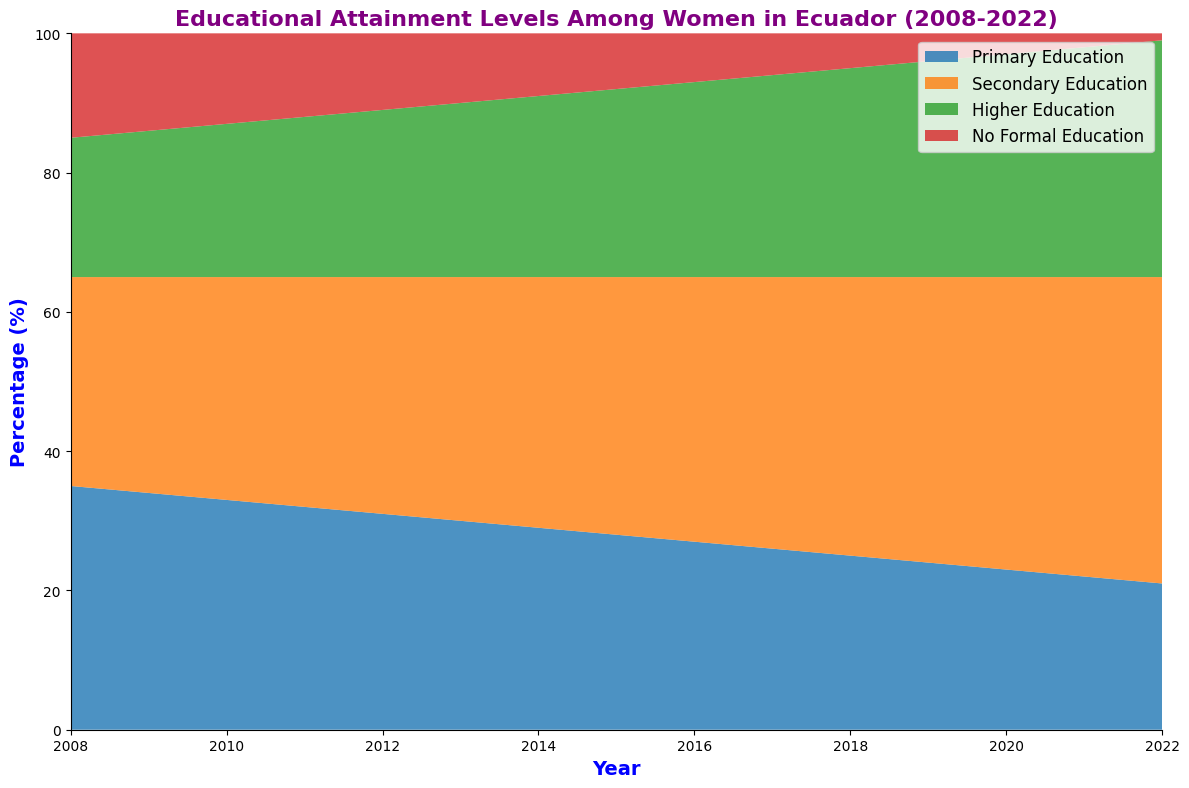What is the overall trend of women's primary education attainment levels over the past 15 years? The primary education attainment level has been decreasing over the past 15 years. The percentage went from 35% in 2008 to 21% in 2022.
Answer: Decreasing Which level of education has seen the highest increase in attainment among women from 2008 to 2022? Secondary education has seen the highest increase, with the percentage rising from 30% in 2008 to 44% in 2022, showing a significant upward trend.
Answer: Secondary Education Has the percentage of women with no formal education increased or decreased from 2008 to 2022? The percentage of women with no formal education has decreased, going from 15% in 2008 to 1% in 2022.
Answer: Decreased In what year did the percentage of women with higher education surpass 30%? The percentage of women with higher education surpassed 30% in the year 2018.
Answer: 2018 Compare the percentage of women with secondary education in 2010 and 2022. In 2010, the percentage of women with secondary education was 32%, whereas in 2022, it was 44%. Therefore, there was a significant increase.
Answer: Increased What was the combined percentage of women with primary and higher education in the year 2016? In 2016, the percentage of women with primary education was 27%, and higher education was 28%. The combined percentage is 27% + 28% = 55%.
Answer: 55% What can you infer about the proportion of women advancing from primary to higher education over the years? The proportion of women advancing from primary to higher education has increased, as evidenced by the decreasing percentage of women in primary education and the increasing percentage in higher education over the years.
Answer: Increased Between 2008 and 2022, what is the total change in the percentage points for women with higher education? In 2008, the percentage of women with higher education was 20%, and in 2022, it was 34%. The total change in percentage points is 34% - 20% = 14%.
Answer: 14% Which educational attainment level had the most stable trend over the 15 years, i.e., the least amount of change? Higher education shows the least variation in its yearly increase, indicating a more stable and consistent upward trend compared to other levels.
Answer: Higher Education Was there any year where the percentage of women with primary education and no formal education combined was less than 30%? In 2022, the combined percentages of women with primary education and no formal education were 21% + 1% = 22%, which is the only year where it was less than 30%.
Answer: 2022 